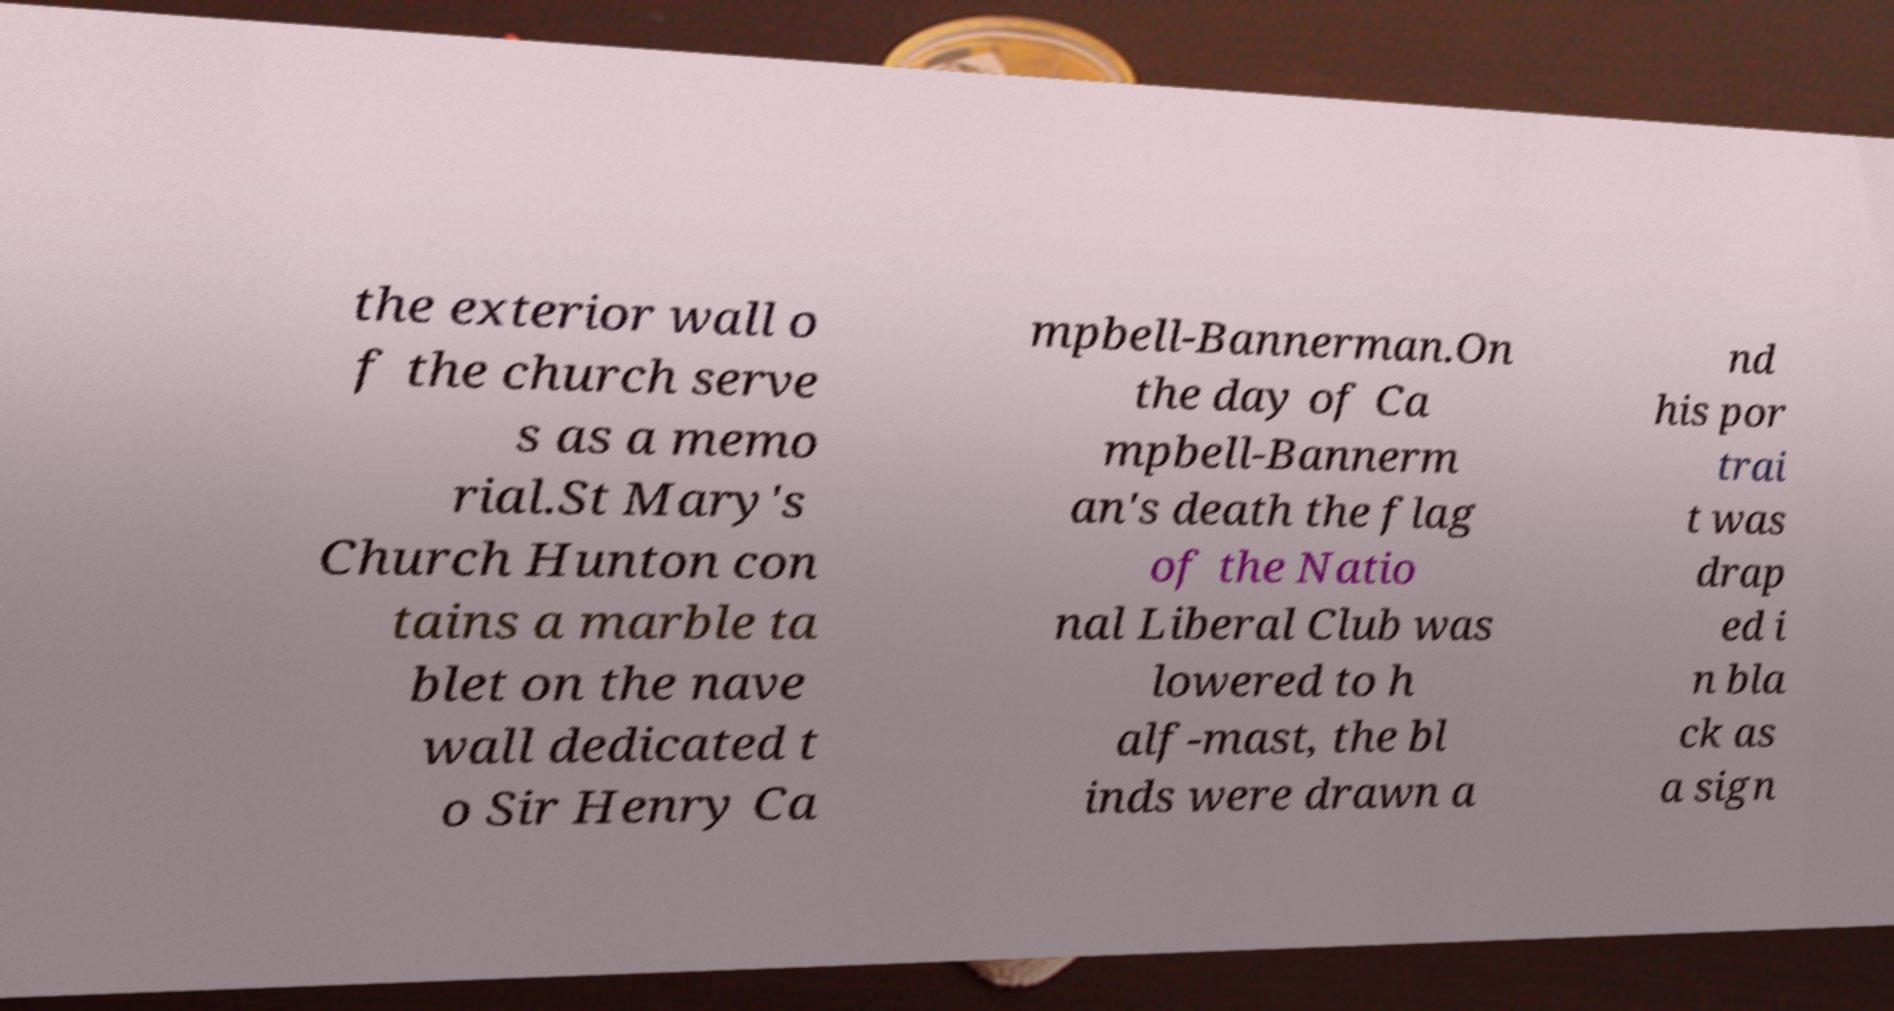Could you assist in decoding the text presented in this image and type it out clearly? the exterior wall o f the church serve s as a memo rial.St Mary's Church Hunton con tains a marble ta blet on the nave wall dedicated t o Sir Henry Ca mpbell-Bannerman.On the day of Ca mpbell-Bannerm an's death the flag of the Natio nal Liberal Club was lowered to h alf-mast, the bl inds were drawn a nd his por trai t was drap ed i n bla ck as a sign 